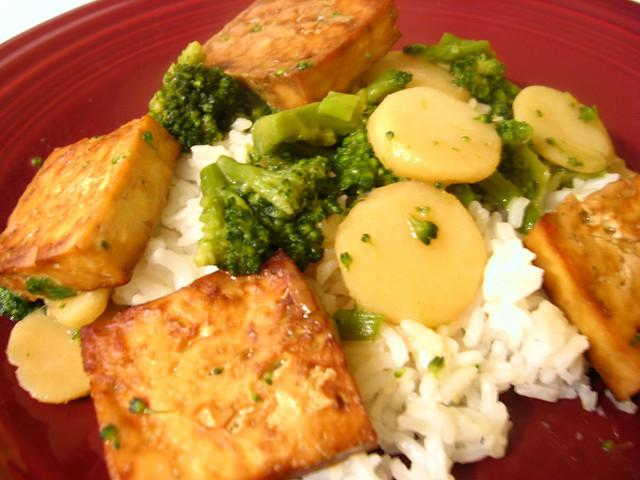Which item on the plate is highest in carbs?

Choices:
A) broccoli
B) squash
C) rice
D) meat rice 